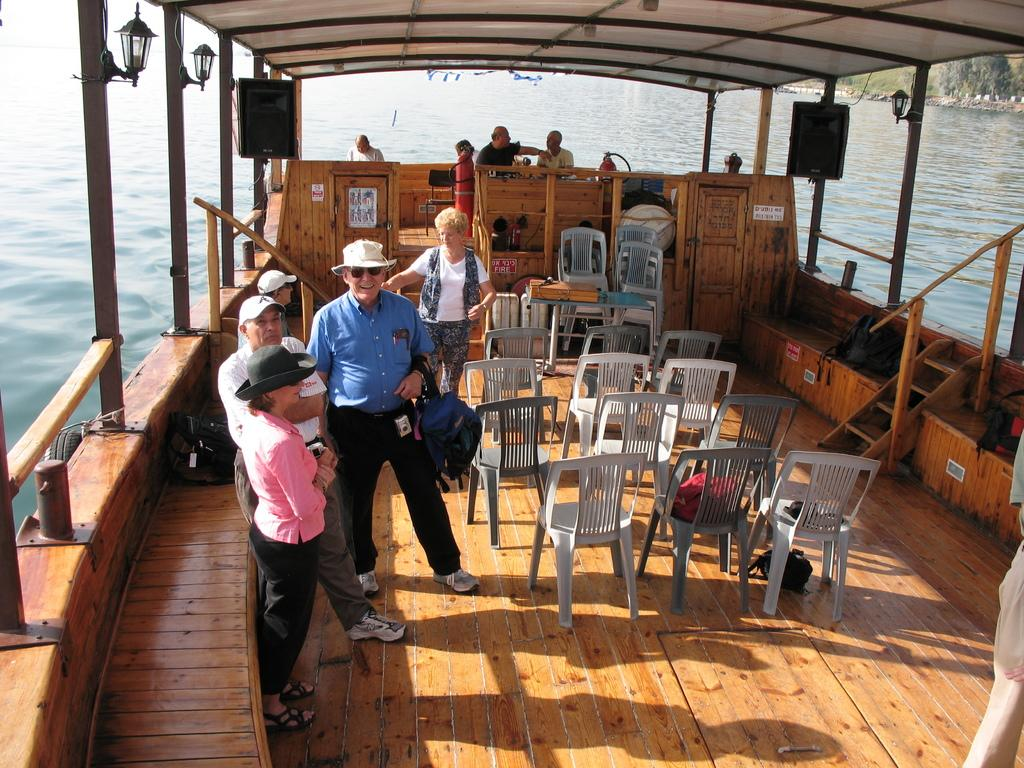Who is present in the image? There is a group of people in the image. What are the people in the image doing? The group of people is traveling on a ship. Can you see the father of the group in the image? There is no information about a father or any specific individuals in the group, so it cannot be determined if the father is present in the image. 